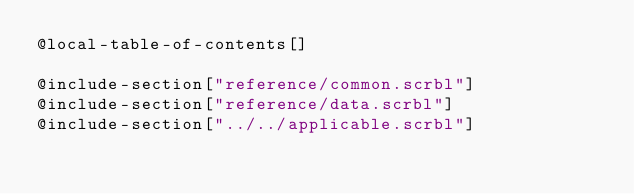<code> <loc_0><loc_0><loc_500><loc_500><_Racket_>@local-table-of-contents[]

@include-section["reference/common.scrbl"]
@include-section["reference/data.scrbl"]
@include-section["../../applicable.scrbl"]
</code> 